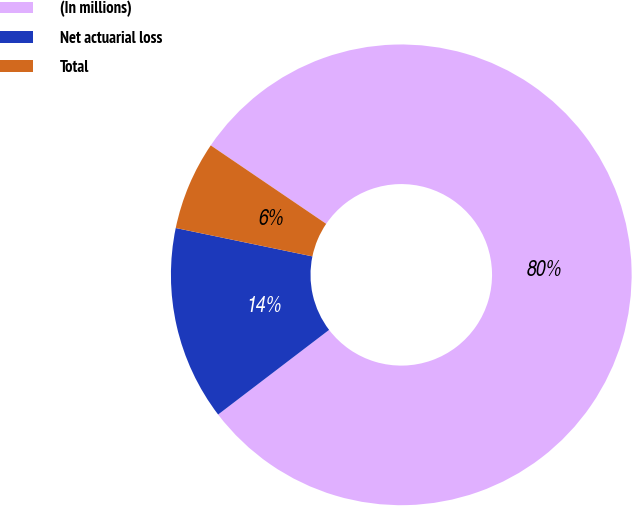Convert chart. <chart><loc_0><loc_0><loc_500><loc_500><pie_chart><fcel>(In millions)<fcel>Net actuarial loss<fcel>Total<nl><fcel>80.14%<fcel>13.63%<fcel>6.24%<nl></chart> 